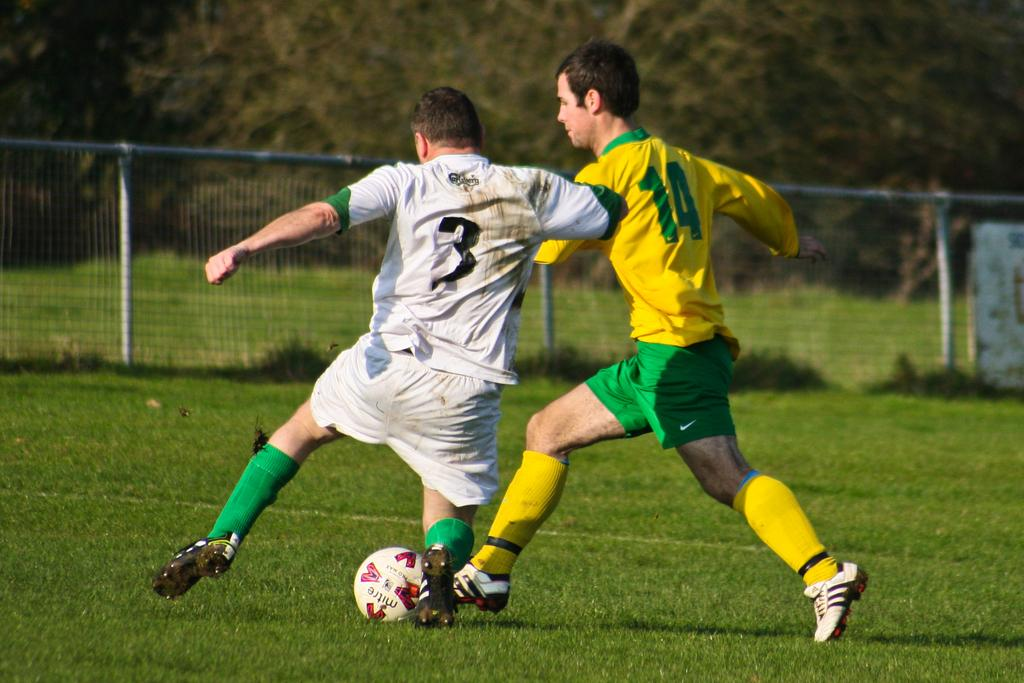How many people are in the image? There are two persons in the image. What are the two persons doing in the image? The two persons are playing in the ground. What object can be seen in the image that is commonly used in games? There is a ball in the image. What can be seen in the background of the image? There is a fence and trees in the background of the image. What type of surface are the two persons playing on? There is grass in the image, so they are playing on grass. Can you see a boat in the image? No, there is no boat present in the image. What type of bit is being used by the monkey in the image? There is no monkey present in the image, so there is no bit being used. 